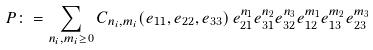<formula> <loc_0><loc_0><loc_500><loc_500>P \colon = \sum _ { n _ { i } , m _ { i } \geq 0 } C _ { n _ { i } , m _ { i } } ( e _ { 1 1 } , e _ { 2 2 } , e _ { 3 3 } ) \, e _ { 2 1 } ^ { n _ { 1 } } e _ { 3 1 } ^ { n _ { 2 } } e _ { 3 2 } ^ { n _ { 3 } } e _ { 1 2 } ^ { m _ { 1 } } e _ { 1 3 } ^ { m _ { 2 } } e _ { 2 3 } ^ { m _ { 3 } }</formula> 